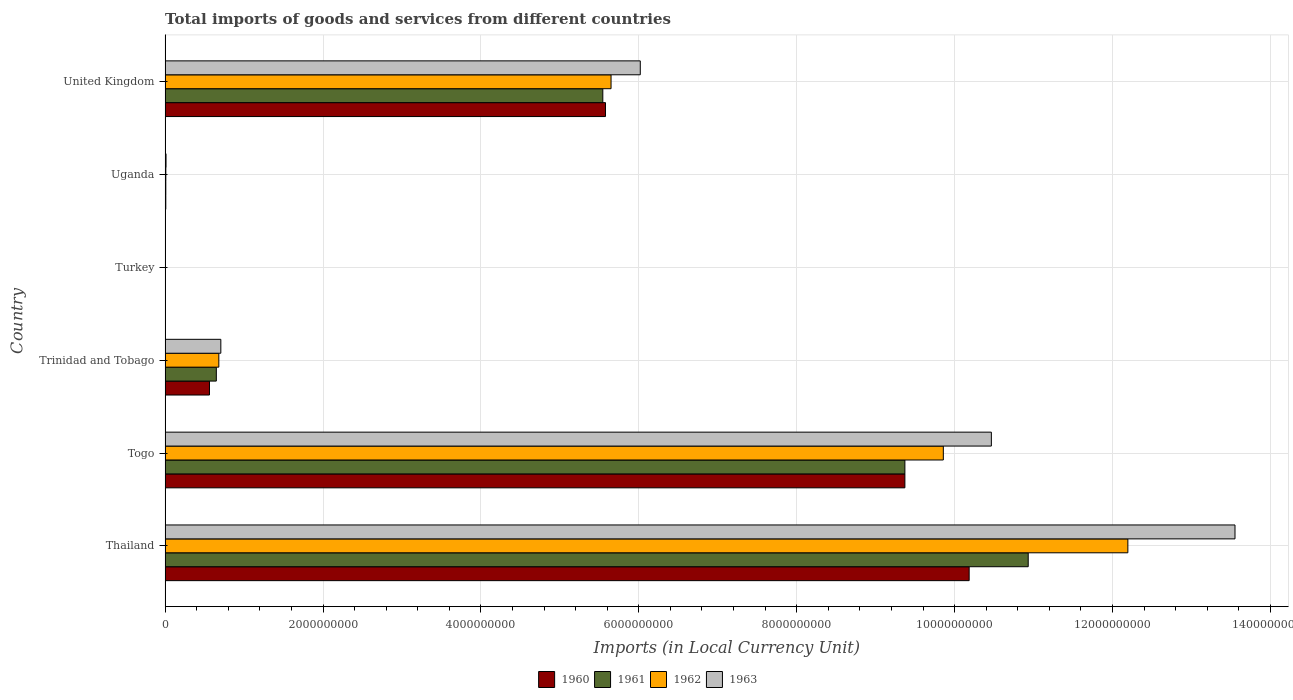What is the label of the 6th group of bars from the top?
Your answer should be very brief. Thailand. In how many cases, is the number of bars for a given country not equal to the number of legend labels?
Provide a short and direct response. 0. What is the Amount of goods and services imports in 1962 in United Kingdom?
Your response must be concise. 5.65e+09. Across all countries, what is the maximum Amount of goods and services imports in 1960?
Provide a short and direct response. 1.02e+1. Across all countries, what is the minimum Amount of goods and services imports in 1961?
Your response must be concise. 4900. In which country was the Amount of goods and services imports in 1960 maximum?
Make the answer very short. Thailand. What is the total Amount of goods and services imports in 1961 in the graph?
Your answer should be compact. 2.65e+1. What is the difference between the Amount of goods and services imports in 1961 in Trinidad and Tobago and that in United Kingdom?
Your answer should be very brief. -4.89e+09. What is the difference between the Amount of goods and services imports in 1962 in Togo and the Amount of goods and services imports in 1963 in Turkey?
Offer a very short reply. 9.86e+09. What is the average Amount of goods and services imports in 1963 per country?
Provide a short and direct response. 5.13e+09. What is the difference between the Amount of goods and services imports in 1962 and Amount of goods and services imports in 1960 in Uganda?
Your response must be concise. 3.83e+05. What is the ratio of the Amount of goods and services imports in 1962 in Togo to that in United Kingdom?
Your answer should be very brief. 1.75. Is the Amount of goods and services imports in 1963 in Thailand less than that in United Kingdom?
Offer a terse response. No. What is the difference between the highest and the second highest Amount of goods and services imports in 1960?
Your answer should be compact. 8.14e+08. What is the difference between the highest and the lowest Amount of goods and services imports in 1963?
Offer a very short reply. 1.36e+1. In how many countries, is the Amount of goods and services imports in 1963 greater than the average Amount of goods and services imports in 1963 taken over all countries?
Offer a terse response. 3. Is the sum of the Amount of goods and services imports in 1962 in Thailand and United Kingdom greater than the maximum Amount of goods and services imports in 1960 across all countries?
Provide a short and direct response. Yes. Is it the case that in every country, the sum of the Amount of goods and services imports in 1961 and Amount of goods and services imports in 1960 is greater than the sum of Amount of goods and services imports in 1963 and Amount of goods and services imports in 1962?
Your answer should be very brief. No. What does the 3rd bar from the top in Uganda represents?
Offer a very short reply. 1961. Are all the bars in the graph horizontal?
Offer a very short reply. Yes. How many countries are there in the graph?
Your response must be concise. 6. Does the graph contain any zero values?
Your answer should be very brief. No. What is the title of the graph?
Your response must be concise. Total imports of goods and services from different countries. Does "1984" appear as one of the legend labels in the graph?
Offer a very short reply. No. What is the label or title of the X-axis?
Your response must be concise. Imports (in Local Currency Unit). What is the label or title of the Y-axis?
Your answer should be compact. Country. What is the Imports (in Local Currency Unit) in 1960 in Thailand?
Provide a succinct answer. 1.02e+1. What is the Imports (in Local Currency Unit) of 1961 in Thailand?
Make the answer very short. 1.09e+1. What is the Imports (in Local Currency Unit) of 1962 in Thailand?
Provide a short and direct response. 1.22e+1. What is the Imports (in Local Currency Unit) in 1963 in Thailand?
Your answer should be very brief. 1.36e+1. What is the Imports (in Local Currency Unit) of 1960 in Togo?
Give a very brief answer. 9.37e+09. What is the Imports (in Local Currency Unit) of 1961 in Togo?
Make the answer very short. 9.37e+09. What is the Imports (in Local Currency Unit) of 1962 in Togo?
Give a very brief answer. 9.86e+09. What is the Imports (in Local Currency Unit) in 1963 in Togo?
Your answer should be very brief. 1.05e+1. What is the Imports (in Local Currency Unit) of 1960 in Trinidad and Tobago?
Offer a very short reply. 5.62e+08. What is the Imports (in Local Currency Unit) in 1961 in Trinidad and Tobago?
Your answer should be very brief. 6.49e+08. What is the Imports (in Local Currency Unit) in 1962 in Trinidad and Tobago?
Your answer should be compact. 6.81e+08. What is the Imports (in Local Currency Unit) in 1963 in Trinidad and Tobago?
Offer a terse response. 7.06e+08. What is the Imports (in Local Currency Unit) in 1960 in Turkey?
Make the answer very short. 2500. What is the Imports (in Local Currency Unit) in 1961 in Turkey?
Provide a succinct answer. 4900. What is the Imports (in Local Currency Unit) of 1962 in Turkey?
Your answer should be very brief. 6400. What is the Imports (in Local Currency Unit) of 1963 in Turkey?
Your answer should be very brief. 6500. What is the Imports (in Local Currency Unit) of 1960 in Uganda?
Your response must be concise. 8.80e+06. What is the Imports (in Local Currency Unit) in 1961 in Uganda?
Keep it short and to the point. 9.12e+06. What is the Imports (in Local Currency Unit) in 1962 in Uganda?
Provide a succinct answer. 9.19e+06. What is the Imports (in Local Currency Unit) in 1963 in Uganda?
Your answer should be very brief. 1.18e+07. What is the Imports (in Local Currency Unit) in 1960 in United Kingdom?
Provide a succinct answer. 5.58e+09. What is the Imports (in Local Currency Unit) of 1961 in United Kingdom?
Provide a short and direct response. 5.54e+09. What is the Imports (in Local Currency Unit) in 1962 in United Kingdom?
Keep it short and to the point. 5.65e+09. What is the Imports (in Local Currency Unit) in 1963 in United Kingdom?
Provide a short and direct response. 6.02e+09. Across all countries, what is the maximum Imports (in Local Currency Unit) in 1960?
Provide a short and direct response. 1.02e+1. Across all countries, what is the maximum Imports (in Local Currency Unit) of 1961?
Keep it short and to the point. 1.09e+1. Across all countries, what is the maximum Imports (in Local Currency Unit) in 1962?
Offer a very short reply. 1.22e+1. Across all countries, what is the maximum Imports (in Local Currency Unit) in 1963?
Give a very brief answer. 1.36e+1. Across all countries, what is the minimum Imports (in Local Currency Unit) of 1960?
Ensure brevity in your answer.  2500. Across all countries, what is the minimum Imports (in Local Currency Unit) of 1961?
Make the answer very short. 4900. Across all countries, what is the minimum Imports (in Local Currency Unit) in 1962?
Offer a terse response. 6400. Across all countries, what is the minimum Imports (in Local Currency Unit) of 1963?
Keep it short and to the point. 6500. What is the total Imports (in Local Currency Unit) in 1960 in the graph?
Provide a succinct answer. 2.57e+1. What is the total Imports (in Local Currency Unit) of 1961 in the graph?
Your answer should be very brief. 2.65e+1. What is the total Imports (in Local Currency Unit) of 1962 in the graph?
Ensure brevity in your answer.  2.84e+1. What is the total Imports (in Local Currency Unit) in 1963 in the graph?
Offer a terse response. 3.08e+1. What is the difference between the Imports (in Local Currency Unit) in 1960 in Thailand and that in Togo?
Your answer should be very brief. 8.14e+08. What is the difference between the Imports (in Local Currency Unit) of 1961 in Thailand and that in Togo?
Your response must be concise. 1.56e+09. What is the difference between the Imports (in Local Currency Unit) in 1962 in Thailand and that in Togo?
Ensure brevity in your answer.  2.34e+09. What is the difference between the Imports (in Local Currency Unit) of 1963 in Thailand and that in Togo?
Make the answer very short. 3.09e+09. What is the difference between the Imports (in Local Currency Unit) in 1960 in Thailand and that in Trinidad and Tobago?
Your answer should be compact. 9.62e+09. What is the difference between the Imports (in Local Currency Unit) in 1961 in Thailand and that in Trinidad and Tobago?
Give a very brief answer. 1.03e+1. What is the difference between the Imports (in Local Currency Unit) of 1962 in Thailand and that in Trinidad and Tobago?
Your response must be concise. 1.15e+1. What is the difference between the Imports (in Local Currency Unit) in 1963 in Thailand and that in Trinidad and Tobago?
Ensure brevity in your answer.  1.28e+1. What is the difference between the Imports (in Local Currency Unit) of 1960 in Thailand and that in Turkey?
Your answer should be compact. 1.02e+1. What is the difference between the Imports (in Local Currency Unit) in 1961 in Thailand and that in Turkey?
Give a very brief answer. 1.09e+1. What is the difference between the Imports (in Local Currency Unit) in 1962 in Thailand and that in Turkey?
Ensure brevity in your answer.  1.22e+1. What is the difference between the Imports (in Local Currency Unit) in 1963 in Thailand and that in Turkey?
Make the answer very short. 1.36e+1. What is the difference between the Imports (in Local Currency Unit) of 1960 in Thailand and that in Uganda?
Keep it short and to the point. 1.02e+1. What is the difference between the Imports (in Local Currency Unit) in 1961 in Thailand and that in Uganda?
Your answer should be compact. 1.09e+1. What is the difference between the Imports (in Local Currency Unit) in 1962 in Thailand and that in Uganda?
Keep it short and to the point. 1.22e+1. What is the difference between the Imports (in Local Currency Unit) of 1963 in Thailand and that in Uganda?
Make the answer very short. 1.35e+1. What is the difference between the Imports (in Local Currency Unit) in 1960 in Thailand and that in United Kingdom?
Make the answer very short. 4.61e+09. What is the difference between the Imports (in Local Currency Unit) in 1961 in Thailand and that in United Kingdom?
Provide a succinct answer. 5.39e+09. What is the difference between the Imports (in Local Currency Unit) in 1962 in Thailand and that in United Kingdom?
Give a very brief answer. 6.55e+09. What is the difference between the Imports (in Local Currency Unit) in 1963 in Thailand and that in United Kingdom?
Offer a very short reply. 7.53e+09. What is the difference between the Imports (in Local Currency Unit) of 1960 in Togo and that in Trinidad and Tobago?
Provide a short and direct response. 8.81e+09. What is the difference between the Imports (in Local Currency Unit) in 1961 in Togo and that in Trinidad and Tobago?
Provide a succinct answer. 8.72e+09. What is the difference between the Imports (in Local Currency Unit) of 1962 in Togo and that in Trinidad and Tobago?
Make the answer very short. 9.18e+09. What is the difference between the Imports (in Local Currency Unit) of 1963 in Togo and that in Trinidad and Tobago?
Give a very brief answer. 9.76e+09. What is the difference between the Imports (in Local Currency Unit) in 1960 in Togo and that in Turkey?
Offer a very short reply. 9.37e+09. What is the difference between the Imports (in Local Currency Unit) of 1961 in Togo and that in Turkey?
Provide a succinct answer. 9.37e+09. What is the difference between the Imports (in Local Currency Unit) of 1962 in Togo and that in Turkey?
Offer a terse response. 9.86e+09. What is the difference between the Imports (in Local Currency Unit) of 1963 in Togo and that in Turkey?
Your response must be concise. 1.05e+1. What is the difference between the Imports (in Local Currency Unit) in 1960 in Togo and that in Uganda?
Ensure brevity in your answer.  9.36e+09. What is the difference between the Imports (in Local Currency Unit) of 1961 in Togo and that in Uganda?
Offer a very short reply. 9.36e+09. What is the difference between the Imports (in Local Currency Unit) of 1962 in Togo and that in Uganda?
Provide a succinct answer. 9.85e+09. What is the difference between the Imports (in Local Currency Unit) of 1963 in Togo and that in Uganda?
Offer a very short reply. 1.05e+1. What is the difference between the Imports (in Local Currency Unit) of 1960 in Togo and that in United Kingdom?
Your answer should be very brief. 3.79e+09. What is the difference between the Imports (in Local Currency Unit) in 1961 in Togo and that in United Kingdom?
Provide a short and direct response. 3.83e+09. What is the difference between the Imports (in Local Currency Unit) in 1962 in Togo and that in United Kingdom?
Your response must be concise. 4.21e+09. What is the difference between the Imports (in Local Currency Unit) in 1963 in Togo and that in United Kingdom?
Provide a succinct answer. 4.45e+09. What is the difference between the Imports (in Local Currency Unit) of 1960 in Trinidad and Tobago and that in Turkey?
Offer a terse response. 5.62e+08. What is the difference between the Imports (in Local Currency Unit) in 1961 in Trinidad and Tobago and that in Turkey?
Make the answer very short. 6.49e+08. What is the difference between the Imports (in Local Currency Unit) in 1962 in Trinidad and Tobago and that in Turkey?
Provide a succinct answer. 6.81e+08. What is the difference between the Imports (in Local Currency Unit) in 1963 in Trinidad and Tobago and that in Turkey?
Your answer should be very brief. 7.06e+08. What is the difference between the Imports (in Local Currency Unit) in 1960 in Trinidad and Tobago and that in Uganda?
Give a very brief answer. 5.53e+08. What is the difference between the Imports (in Local Currency Unit) of 1961 in Trinidad and Tobago and that in Uganda?
Make the answer very short. 6.40e+08. What is the difference between the Imports (in Local Currency Unit) of 1962 in Trinidad and Tobago and that in Uganda?
Provide a succinct answer. 6.71e+08. What is the difference between the Imports (in Local Currency Unit) in 1963 in Trinidad and Tobago and that in Uganda?
Keep it short and to the point. 6.94e+08. What is the difference between the Imports (in Local Currency Unit) of 1960 in Trinidad and Tobago and that in United Kingdom?
Make the answer very short. -5.02e+09. What is the difference between the Imports (in Local Currency Unit) in 1961 in Trinidad and Tobago and that in United Kingdom?
Your response must be concise. -4.89e+09. What is the difference between the Imports (in Local Currency Unit) in 1962 in Trinidad and Tobago and that in United Kingdom?
Your answer should be very brief. -4.97e+09. What is the difference between the Imports (in Local Currency Unit) in 1963 in Trinidad and Tobago and that in United Kingdom?
Offer a very short reply. -5.31e+09. What is the difference between the Imports (in Local Currency Unit) in 1960 in Turkey and that in Uganda?
Make the answer very short. -8.80e+06. What is the difference between the Imports (in Local Currency Unit) in 1961 in Turkey and that in Uganda?
Offer a terse response. -9.11e+06. What is the difference between the Imports (in Local Currency Unit) in 1962 in Turkey and that in Uganda?
Offer a very short reply. -9.18e+06. What is the difference between the Imports (in Local Currency Unit) in 1963 in Turkey and that in Uganda?
Your response must be concise. -1.18e+07. What is the difference between the Imports (in Local Currency Unit) in 1960 in Turkey and that in United Kingdom?
Keep it short and to the point. -5.58e+09. What is the difference between the Imports (in Local Currency Unit) in 1961 in Turkey and that in United Kingdom?
Your answer should be very brief. -5.54e+09. What is the difference between the Imports (in Local Currency Unit) of 1962 in Turkey and that in United Kingdom?
Give a very brief answer. -5.65e+09. What is the difference between the Imports (in Local Currency Unit) of 1963 in Turkey and that in United Kingdom?
Offer a terse response. -6.02e+09. What is the difference between the Imports (in Local Currency Unit) of 1960 in Uganda and that in United Kingdom?
Provide a short and direct response. -5.57e+09. What is the difference between the Imports (in Local Currency Unit) in 1961 in Uganda and that in United Kingdom?
Offer a terse response. -5.53e+09. What is the difference between the Imports (in Local Currency Unit) of 1962 in Uganda and that in United Kingdom?
Ensure brevity in your answer.  -5.64e+09. What is the difference between the Imports (in Local Currency Unit) in 1963 in Uganda and that in United Kingdom?
Ensure brevity in your answer.  -6.01e+09. What is the difference between the Imports (in Local Currency Unit) of 1960 in Thailand and the Imports (in Local Currency Unit) of 1961 in Togo?
Keep it short and to the point. 8.14e+08. What is the difference between the Imports (in Local Currency Unit) in 1960 in Thailand and the Imports (in Local Currency Unit) in 1962 in Togo?
Your answer should be compact. 3.27e+08. What is the difference between the Imports (in Local Currency Unit) in 1960 in Thailand and the Imports (in Local Currency Unit) in 1963 in Togo?
Ensure brevity in your answer.  -2.81e+08. What is the difference between the Imports (in Local Currency Unit) of 1961 in Thailand and the Imports (in Local Currency Unit) of 1962 in Togo?
Your answer should be compact. 1.08e+09. What is the difference between the Imports (in Local Currency Unit) of 1961 in Thailand and the Imports (in Local Currency Unit) of 1963 in Togo?
Keep it short and to the point. 4.67e+08. What is the difference between the Imports (in Local Currency Unit) in 1962 in Thailand and the Imports (in Local Currency Unit) in 1963 in Togo?
Offer a very short reply. 1.73e+09. What is the difference between the Imports (in Local Currency Unit) in 1960 in Thailand and the Imports (in Local Currency Unit) in 1961 in Trinidad and Tobago?
Make the answer very short. 9.54e+09. What is the difference between the Imports (in Local Currency Unit) in 1960 in Thailand and the Imports (in Local Currency Unit) in 1962 in Trinidad and Tobago?
Your response must be concise. 9.50e+09. What is the difference between the Imports (in Local Currency Unit) in 1960 in Thailand and the Imports (in Local Currency Unit) in 1963 in Trinidad and Tobago?
Offer a terse response. 9.48e+09. What is the difference between the Imports (in Local Currency Unit) of 1961 in Thailand and the Imports (in Local Currency Unit) of 1962 in Trinidad and Tobago?
Make the answer very short. 1.03e+1. What is the difference between the Imports (in Local Currency Unit) of 1961 in Thailand and the Imports (in Local Currency Unit) of 1963 in Trinidad and Tobago?
Ensure brevity in your answer.  1.02e+1. What is the difference between the Imports (in Local Currency Unit) in 1962 in Thailand and the Imports (in Local Currency Unit) in 1963 in Trinidad and Tobago?
Your answer should be compact. 1.15e+1. What is the difference between the Imports (in Local Currency Unit) of 1960 in Thailand and the Imports (in Local Currency Unit) of 1961 in Turkey?
Provide a succinct answer. 1.02e+1. What is the difference between the Imports (in Local Currency Unit) in 1960 in Thailand and the Imports (in Local Currency Unit) in 1962 in Turkey?
Give a very brief answer. 1.02e+1. What is the difference between the Imports (in Local Currency Unit) of 1960 in Thailand and the Imports (in Local Currency Unit) of 1963 in Turkey?
Keep it short and to the point. 1.02e+1. What is the difference between the Imports (in Local Currency Unit) of 1961 in Thailand and the Imports (in Local Currency Unit) of 1962 in Turkey?
Keep it short and to the point. 1.09e+1. What is the difference between the Imports (in Local Currency Unit) in 1961 in Thailand and the Imports (in Local Currency Unit) in 1963 in Turkey?
Provide a short and direct response. 1.09e+1. What is the difference between the Imports (in Local Currency Unit) of 1962 in Thailand and the Imports (in Local Currency Unit) of 1963 in Turkey?
Your response must be concise. 1.22e+1. What is the difference between the Imports (in Local Currency Unit) in 1960 in Thailand and the Imports (in Local Currency Unit) in 1961 in Uganda?
Your response must be concise. 1.02e+1. What is the difference between the Imports (in Local Currency Unit) of 1960 in Thailand and the Imports (in Local Currency Unit) of 1962 in Uganda?
Provide a succinct answer. 1.02e+1. What is the difference between the Imports (in Local Currency Unit) in 1960 in Thailand and the Imports (in Local Currency Unit) in 1963 in Uganda?
Offer a terse response. 1.02e+1. What is the difference between the Imports (in Local Currency Unit) of 1961 in Thailand and the Imports (in Local Currency Unit) of 1962 in Uganda?
Provide a succinct answer. 1.09e+1. What is the difference between the Imports (in Local Currency Unit) of 1961 in Thailand and the Imports (in Local Currency Unit) of 1963 in Uganda?
Offer a very short reply. 1.09e+1. What is the difference between the Imports (in Local Currency Unit) in 1962 in Thailand and the Imports (in Local Currency Unit) in 1963 in Uganda?
Offer a very short reply. 1.22e+1. What is the difference between the Imports (in Local Currency Unit) of 1960 in Thailand and the Imports (in Local Currency Unit) of 1961 in United Kingdom?
Give a very brief answer. 4.64e+09. What is the difference between the Imports (in Local Currency Unit) of 1960 in Thailand and the Imports (in Local Currency Unit) of 1962 in United Kingdom?
Keep it short and to the point. 4.54e+09. What is the difference between the Imports (in Local Currency Unit) of 1960 in Thailand and the Imports (in Local Currency Unit) of 1963 in United Kingdom?
Your answer should be very brief. 4.17e+09. What is the difference between the Imports (in Local Currency Unit) of 1961 in Thailand and the Imports (in Local Currency Unit) of 1962 in United Kingdom?
Your answer should be very brief. 5.28e+09. What is the difference between the Imports (in Local Currency Unit) of 1961 in Thailand and the Imports (in Local Currency Unit) of 1963 in United Kingdom?
Make the answer very short. 4.91e+09. What is the difference between the Imports (in Local Currency Unit) of 1962 in Thailand and the Imports (in Local Currency Unit) of 1963 in United Kingdom?
Your response must be concise. 6.18e+09. What is the difference between the Imports (in Local Currency Unit) of 1960 in Togo and the Imports (in Local Currency Unit) of 1961 in Trinidad and Tobago?
Your answer should be compact. 8.72e+09. What is the difference between the Imports (in Local Currency Unit) in 1960 in Togo and the Imports (in Local Currency Unit) in 1962 in Trinidad and Tobago?
Your answer should be compact. 8.69e+09. What is the difference between the Imports (in Local Currency Unit) of 1960 in Togo and the Imports (in Local Currency Unit) of 1963 in Trinidad and Tobago?
Provide a succinct answer. 8.66e+09. What is the difference between the Imports (in Local Currency Unit) of 1961 in Togo and the Imports (in Local Currency Unit) of 1962 in Trinidad and Tobago?
Provide a short and direct response. 8.69e+09. What is the difference between the Imports (in Local Currency Unit) of 1961 in Togo and the Imports (in Local Currency Unit) of 1963 in Trinidad and Tobago?
Keep it short and to the point. 8.66e+09. What is the difference between the Imports (in Local Currency Unit) of 1962 in Togo and the Imports (in Local Currency Unit) of 1963 in Trinidad and Tobago?
Provide a succinct answer. 9.15e+09. What is the difference between the Imports (in Local Currency Unit) in 1960 in Togo and the Imports (in Local Currency Unit) in 1961 in Turkey?
Offer a terse response. 9.37e+09. What is the difference between the Imports (in Local Currency Unit) of 1960 in Togo and the Imports (in Local Currency Unit) of 1962 in Turkey?
Offer a very short reply. 9.37e+09. What is the difference between the Imports (in Local Currency Unit) in 1960 in Togo and the Imports (in Local Currency Unit) in 1963 in Turkey?
Make the answer very short. 9.37e+09. What is the difference between the Imports (in Local Currency Unit) of 1961 in Togo and the Imports (in Local Currency Unit) of 1962 in Turkey?
Keep it short and to the point. 9.37e+09. What is the difference between the Imports (in Local Currency Unit) of 1961 in Togo and the Imports (in Local Currency Unit) of 1963 in Turkey?
Give a very brief answer. 9.37e+09. What is the difference between the Imports (in Local Currency Unit) in 1962 in Togo and the Imports (in Local Currency Unit) in 1963 in Turkey?
Ensure brevity in your answer.  9.86e+09. What is the difference between the Imports (in Local Currency Unit) of 1960 in Togo and the Imports (in Local Currency Unit) of 1961 in Uganda?
Make the answer very short. 9.36e+09. What is the difference between the Imports (in Local Currency Unit) of 1960 in Togo and the Imports (in Local Currency Unit) of 1962 in Uganda?
Ensure brevity in your answer.  9.36e+09. What is the difference between the Imports (in Local Currency Unit) of 1960 in Togo and the Imports (in Local Currency Unit) of 1963 in Uganda?
Give a very brief answer. 9.36e+09. What is the difference between the Imports (in Local Currency Unit) in 1961 in Togo and the Imports (in Local Currency Unit) in 1962 in Uganda?
Provide a succinct answer. 9.36e+09. What is the difference between the Imports (in Local Currency Unit) in 1961 in Togo and the Imports (in Local Currency Unit) in 1963 in Uganda?
Make the answer very short. 9.36e+09. What is the difference between the Imports (in Local Currency Unit) in 1962 in Togo and the Imports (in Local Currency Unit) in 1963 in Uganda?
Make the answer very short. 9.85e+09. What is the difference between the Imports (in Local Currency Unit) in 1960 in Togo and the Imports (in Local Currency Unit) in 1961 in United Kingdom?
Your answer should be very brief. 3.83e+09. What is the difference between the Imports (in Local Currency Unit) of 1960 in Togo and the Imports (in Local Currency Unit) of 1962 in United Kingdom?
Your response must be concise. 3.72e+09. What is the difference between the Imports (in Local Currency Unit) of 1960 in Togo and the Imports (in Local Currency Unit) of 1963 in United Kingdom?
Your answer should be very brief. 3.35e+09. What is the difference between the Imports (in Local Currency Unit) of 1961 in Togo and the Imports (in Local Currency Unit) of 1962 in United Kingdom?
Provide a succinct answer. 3.72e+09. What is the difference between the Imports (in Local Currency Unit) of 1961 in Togo and the Imports (in Local Currency Unit) of 1963 in United Kingdom?
Give a very brief answer. 3.35e+09. What is the difference between the Imports (in Local Currency Unit) of 1962 in Togo and the Imports (in Local Currency Unit) of 1963 in United Kingdom?
Give a very brief answer. 3.84e+09. What is the difference between the Imports (in Local Currency Unit) of 1960 in Trinidad and Tobago and the Imports (in Local Currency Unit) of 1961 in Turkey?
Keep it short and to the point. 5.62e+08. What is the difference between the Imports (in Local Currency Unit) of 1960 in Trinidad and Tobago and the Imports (in Local Currency Unit) of 1962 in Turkey?
Give a very brief answer. 5.62e+08. What is the difference between the Imports (in Local Currency Unit) in 1960 in Trinidad and Tobago and the Imports (in Local Currency Unit) in 1963 in Turkey?
Provide a short and direct response. 5.62e+08. What is the difference between the Imports (in Local Currency Unit) in 1961 in Trinidad and Tobago and the Imports (in Local Currency Unit) in 1962 in Turkey?
Offer a very short reply. 6.49e+08. What is the difference between the Imports (in Local Currency Unit) of 1961 in Trinidad and Tobago and the Imports (in Local Currency Unit) of 1963 in Turkey?
Offer a very short reply. 6.49e+08. What is the difference between the Imports (in Local Currency Unit) in 1962 in Trinidad and Tobago and the Imports (in Local Currency Unit) in 1963 in Turkey?
Your answer should be very brief. 6.81e+08. What is the difference between the Imports (in Local Currency Unit) in 1960 in Trinidad and Tobago and the Imports (in Local Currency Unit) in 1961 in Uganda?
Your answer should be very brief. 5.53e+08. What is the difference between the Imports (in Local Currency Unit) in 1960 in Trinidad and Tobago and the Imports (in Local Currency Unit) in 1962 in Uganda?
Your answer should be compact. 5.53e+08. What is the difference between the Imports (in Local Currency Unit) in 1960 in Trinidad and Tobago and the Imports (in Local Currency Unit) in 1963 in Uganda?
Your answer should be compact. 5.50e+08. What is the difference between the Imports (in Local Currency Unit) of 1961 in Trinidad and Tobago and the Imports (in Local Currency Unit) of 1962 in Uganda?
Ensure brevity in your answer.  6.40e+08. What is the difference between the Imports (in Local Currency Unit) in 1961 in Trinidad and Tobago and the Imports (in Local Currency Unit) in 1963 in Uganda?
Give a very brief answer. 6.37e+08. What is the difference between the Imports (in Local Currency Unit) of 1962 in Trinidad and Tobago and the Imports (in Local Currency Unit) of 1963 in Uganda?
Give a very brief answer. 6.69e+08. What is the difference between the Imports (in Local Currency Unit) of 1960 in Trinidad and Tobago and the Imports (in Local Currency Unit) of 1961 in United Kingdom?
Keep it short and to the point. -4.98e+09. What is the difference between the Imports (in Local Currency Unit) in 1960 in Trinidad and Tobago and the Imports (in Local Currency Unit) in 1962 in United Kingdom?
Make the answer very short. -5.09e+09. What is the difference between the Imports (in Local Currency Unit) of 1960 in Trinidad and Tobago and the Imports (in Local Currency Unit) of 1963 in United Kingdom?
Make the answer very short. -5.46e+09. What is the difference between the Imports (in Local Currency Unit) of 1961 in Trinidad and Tobago and the Imports (in Local Currency Unit) of 1962 in United Kingdom?
Your answer should be very brief. -5.00e+09. What is the difference between the Imports (in Local Currency Unit) in 1961 in Trinidad and Tobago and the Imports (in Local Currency Unit) in 1963 in United Kingdom?
Your answer should be very brief. -5.37e+09. What is the difference between the Imports (in Local Currency Unit) in 1962 in Trinidad and Tobago and the Imports (in Local Currency Unit) in 1963 in United Kingdom?
Make the answer very short. -5.34e+09. What is the difference between the Imports (in Local Currency Unit) in 1960 in Turkey and the Imports (in Local Currency Unit) in 1961 in Uganda?
Offer a very short reply. -9.11e+06. What is the difference between the Imports (in Local Currency Unit) of 1960 in Turkey and the Imports (in Local Currency Unit) of 1962 in Uganda?
Your response must be concise. -9.18e+06. What is the difference between the Imports (in Local Currency Unit) in 1960 in Turkey and the Imports (in Local Currency Unit) in 1963 in Uganda?
Offer a very short reply. -1.18e+07. What is the difference between the Imports (in Local Currency Unit) of 1961 in Turkey and the Imports (in Local Currency Unit) of 1962 in Uganda?
Your response must be concise. -9.18e+06. What is the difference between the Imports (in Local Currency Unit) in 1961 in Turkey and the Imports (in Local Currency Unit) in 1963 in Uganda?
Make the answer very short. -1.18e+07. What is the difference between the Imports (in Local Currency Unit) of 1962 in Turkey and the Imports (in Local Currency Unit) of 1963 in Uganda?
Your response must be concise. -1.18e+07. What is the difference between the Imports (in Local Currency Unit) of 1960 in Turkey and the Imports (in Local Currency Unit) of 1961 in United Kingdom?
Keep it short and to the point. -5.54e+09. What is the difference between the Imports (in Local Currency Unit) of 1960 in Turkey and the Imports (in Local Currency Unit) of 1962 in United Kingdom?
Keep it short and to the point. -5.65e+09. What is the difference between the Imports (in Local Currency Unit) of 1960 in Turkey and the Imports (in Local Currency Unit) of 1963 in United Kingdom?
Offer a very short reply. -6.02e+09. What is the difference between the Imports (in Local Currency Unit) in 1961 in Turkey and the Imports (in Local Currency Unit) in 1962 in United Kingdom?
Offer a very short reply. -5.65e+09. What is the difference between the Imports (in Local Currency Unit) in 1961 in Turkey and the Imports (in Local Currency Unit) in 1963 in United Kingdom?
Make the answer very short. -6.02e+09. What is the difference between the Imports (in Local Currency Unit) of 1962 in Turkey and the Imports (in Local Currency Unit) of 1963 in United Kingdom?
Ensure brevity in your answer.  -6.02e+09. What is the difference between the Imports (in Local Currency Unit) in 1960 in Uganda and the Imports (in Local Currency Unit) in 1961 in United Kingdom?
Your answer should be compact. -5.54e+09. What is the difference between the Imports (in Local Currency Unit) in 1960 in Uganda and the Imports (in Local Currency Unit) in 1962 in United Kingdom?
Keep it short and to the point. -5.64e+09. What is the difference between the Imports (in Local Currency Unit) in 1960 in Uganda and the Imports (in Local Currency Unit) in 1963 in United Kingdom?
Offer a terse response. -6.01e+09. What is the difference between the Imports (in Local Currency Unit) in 1961 in Uganda and the Imports (in Local Currency Unit) in 1962 in United Kingdom?
Offer a very short reply. -5.64e+09. What is the difference between the Imports (in Local Currency Unit) in 1961 in Uganda and the Imports (in Local Currency Unit) in 1963 in United Kingdom?
Offer a very short reply. -6.01e+09. What is the difference between the Imports (in Local Currency Unit) in 1962 in Uganda and the Imports (in Local Currency Unit) in 1963 in United Kingdom?
Your answer should be very brief. -6.01e+09. What is the average Imports (in Local Currency Unit) of 1960 per country?
Offer a very short reply. 4.28e+09. What is the average Imports (in Local Currency Unit) in 1961 per country?
Your response must be concise. 4.42e+09. What is the average Imports (in Local Currency Unit) in 1962 per country?
Provide a succinct answer. 4.73e+09. What is the average Imports (in Local Currency Unit) in 1963 per country?
Your response must be concise. 5.13e+09. What is the difference between the Imports (in Local Currency Unit) of 1960 and Imports (in Local Currency Unit) of 1961 in Thailand?
Offer a very short reply. -7.48e+08. What is the difference between the Imports (in Local Currency Unit) of 1960 and Imports (in Local Currency Unit) of 1962 in Thailand?
Make the answer very short. -2.01e+09. What is the difference between the Imports (in Local Currency Unit) of 1960 and Imports (in Local Currency Unit) of 1963 in Thailand?
Your response must be concise. -3.37e+09. What is the difference between the Imports (in Local Currency Unit) in 1961 and Imports (in Local Currency Unit) in 1962 in Thailand?
Your answer should be compact. -1.26e+09. What is the difference between the Imports (in Local Currency Unit) of 1961 and Imports (in Local Currency Unit) of 1963 in Thailand?
Provide a succinct answer. -2.62e+09. What is the difference between the Imports (in Local Currency Unit) of 1962 and Imports (in Local Currency Unit) of 1963 in Thailand?
Offer a terse response. -1.36e+09. What is the difference between the Imports (in Local Currency Unit) of 1960 and Imports (in Local Currency Unit) of 1962 in Togo?
Offer a terse response. -4.87e+08. What is the difference between the Imports (in Local Currency Unit) in 1960 and Imports (in Local Currency Unit) in 1963 in Togo?
Provide a short and direct response. -1.10e+09. What is the difference between the Imports (in Local Currency Unit) in 1961 and Imports (in Local Currency Unit) in 1962 in Togo?
Ensure brevity in your answer.  -4.87e+08. What is the difference between the Imports (in Local Currency Unit) in 1961 and Imports (in Local Currency Unit) in 1963 in Togo?
Give a very brief answer. -1.10e+09. What is the difference between the Imports (in Local Currency Unit) in 1962 and Imports (in Local Currency Unit) in 1963 in Togo?
Your response must be concise. -6.08e+08. What is the difference between the Imports (in Local Currency Unit) of 1960 and Imports (in Local Currency Unit) of 1961 in Trinidad and Tobago?
Offer a terse response. -8.67e+07. What is the difference between the Imports (in Local Currency Unit) of 1960 and Imports (in Local Currency Unit) of 1962 in Trinidad and Tobago?
Give a very brief answer. -1.18e+08. What is the difference between the Imports (in Local Currency Unit) in 1960 and Imports (in Local Currency Unit) in 1963 in Trinidad and Tobago?
Your answer should be compact. -1.44e+08. What is the difference between the Imports (in Local Currency Unit) in 1961 and Imports (in Local Currency Unit) in 1962 in Trinidad and Tobago?
Your response must be concise. -3.17e+07. What is the difference between the Imports (in Local Currency Unit) of 1961 and Imports (in Local Currency Unit) of 1963 in Trinidad and Tobago?
Your response must be concise. -5.69e+07. What is the difference between the Imports (in Local Currency Unit) in 1962 and Imports (in Local Currency Unit) in 1963 in Trinidad and Tobago?
Provide a succinct answer. -2.52e+07. What is the difference between the Imports (in Local Currency Unit) in 1960 and Imports (in Local Currency Unit) in 1961 in Turkey?
Ensure brevity in your answer.  -2400. What is the difference between the Imports (in Local Currency Unit) in 1960 and Imports (in Local Currency Unit) in 1962 in Turkey?
Offer a terse response. -3900. What is the difference between the Imports (in Local Currency Unit) of 1960 and Imports (in Local Currency Unit) of 1963 in Turkey?
Offer a terse response. -4000. What is the difference between the Imports (in Local Currency Unit) in 1961 and Imports (in Local Currency Unit) in 1962 in Turkey?
Offer a terse response. -1500. What is the difference between the Imports (in Local Currency Unit) in 1961 and Imports (in Local Currency Unit) in 1963 in Turkey?
Provide a succinct answer. -1600. What is the difference between the Imports (in Local Currency Unit) in 1962 and Imports (in Local Currency Unit) in 1963 in Turkey?
Your response must be concise. -100. What is the difference between the Imports (in Local Currency Unit) of 1960 and Imports (in Local Currency Unit) of 1961 in Uganda?
Your answer should be very brief. -3.13e+05. What is the difference between the Imports (in Local Currency Unit) in 1960 and Imports (in Local Currency Unit) in 1962 in Uganda?
Your answer should be compact. -3.83e+05. What is the difference between the Imports (in Local Currency Unit) of 1960 and Imports (in Local Currency Unit) of 1963 in Uganda?
Keep it short and to the point. -2.95e+06. What is the difference between the Imports (in Local Currency Unit) of 1961 and Imports (in Local Currency Unit) of 1962 in Uganda?
Your answer should be compact. -7.06e+04. What is the difference between the Imports (in Local Currency Unit) in 1961 and Imports (in Local Currency Unit) in 1963 in Uganda?
Offer a very short reply. -2.64e+06. What is the difference between the Imports (in Local Currency Unit) in 1962 and Imports (in Local Currency Unit) in 1963 in Uganda?
Keep it short and to the point. -2.57e+06. What is the difference between the Imports (in Local Currency Unit) in 1960 and Imports (in Local Currency Unit) in 1961 in United Kingdom?
Offer a very short reply. 3.38e+07. What is the difference between the Imports (in Local Currency Unit) of 1960 and Imports (in Local Currency Unit) of 1962 in United Kingdom?
Ensure brevity in your answer.  -7.06e+07. What is the difference between the Imports (in Local Currency Unit) in 1960 and Imports (in Local Currency Unit) in 1963 in United Kingdom?
Provide a short and direct response. -4.41e+08. What is the difference between the Imports (in Local Currency Unit) of 1961 and Imports (in Local Currency Unit) of 1962 in United Kingdom?
Your answer should be very brief. -1.04e+08. What is the difference between the Imports (in Local Currency Unit) of 1961 and Imports (in Local Currency Unit) of 1963 in United Kingdom?
Provide a succinct answer. -4.75e+08. What is the difference between the Imports (in Local Currency Unit) of 1962 and Imports (in Local Currency Unit) of 1963 in United Kingdom?
Make the answer very short. -3.70e+08. What is the ratio of the Imports (in Local Currency Unit) of 1960 in Thailand to that in Togo?
Make the answer very short. 1.09. What is the ratio of the Imports (in Local Currency Unit) in 1962 in Thailand to that in Togo?
Your answer should be compact. 1.24. What is the ratio of the Imports (in Local Currency Unit) in 1963 in Thailand to that in Togo?
Offer a very short reply. 1.29. What is the ratio of the Imports (in Local Currency Unit) in 1960 in Thailand to that in Trinidad and Tobago?
Ensure brevity in your answer.  18.11. What is the ratio of the Imports (in Local Currency Unit) in 1961 in Thailand to that in Trinidad and Tobago?
Give a very brief answer. 16.85. What is the ratio of the Imports (in Local Currency Unit) of 1962 in Thailand to that in Trinidad and Tobago?
Your answer should be compact. 17.92. What is the ratio of the Imports (in Local Currency Unit) of 1963 in Thailand to that in Trinidad and Tobago?
Offer a very short reply. 19.2. What is the ratio of the Imports (in Local Currency Unit) in 1960 in Thailand to that in Turkey?
Ensure brevity in your answer.  4.07e+06. What is the ratio of the Imports (in Local Currency Unit) of 1961 in Thailand to that in Turkey?
Offer a very short reply. 2.23e+06. What is the ratio of the Imports (in Local Currency Unit) of 1962 in Thailand to that in Turkey?
Ensure brevity in your answer.  1.91e+06. What is the ratio of the Imports (in Local Currency Unit) of 1963 in Thailand to that in Turkey?
Your answer should be compact. 2.08e+06. What is the ratio of the Imports (in Local Currency Unit) of 1960 in Thailand to that in Uganda?
Keep it short and to the point. 1156.75. What is the ratio of the Imports (in Local Currency Unit) in 1961 in Thailand to that in Uganda?
Your answer should be very brief. 1199.12. What is the ratio of the Imports (in Local Currency Unit) in 1962 in Thailand to that in Uganda?
Give a very brief answer. 1327.27. What is the ratio of the Imports (in Local Currency Unit) in 1963 in Thailand to that in Uganda?
Your response must be concise. 1152.4. What is the ratio of the Imports (in Local Currency Unit) in 1960 in Thailand to that in United Kingdom?
Ensure brevity in your answer.  1.83. What is the ratio of the Imports (in Local Currency Unit) in 1961 in Thailand to that in United Kingdom?
Your answer should be compact. 1.97. What is the ratio of the Imports (in Local Currency Unit) of 1962 in Thailand to that in United Kingdom?
Keep it short and to the point. 2.16. What is the ratio of the Imports (in Local Currency Unit) in 1963 in Thailand to that in United Kingdom?
Keep it short and to the point. 2.25. What is the ratio of the Imports (in Local Currency Unit) of 1960 in Togo to that in Trinidad and Tobago?
Your answer should be very brief. 16.67. What is the ratio of the Imports (in Local Currency Unit) in 1961 in Togo to that in Trinidad and Tobago?
Keep it short and to the point. 14.44. What is the ratio of the Imports (in Local Currency Unit) of 1962 in Togo to that in Trinidad and Tobago?
Ensure brevity in your answer.  14.48. What is the ratio of the Imports (in Local Currency Unit) in 1963 in Togo to that in Trinidad and Tobago?
Your answer should be compact. 14.83. What is the ratio of the Imports (in Local Currency Unit) of 1960 in Togo to that in Turkey?
Ensure brevity in your answer.  3.75e+06. What is the ratio of the Imports (in Local Currency Unit) of 1961 in Togo to that in Turkey?
Ensure brevity in your answer.  1.91e+06. What is the ratio of the Imports (in Local Currency Unit) in 1962 in Togo to that in Turkey?
Your answer should be compact. 1.54e+06. What is the ratio of the Imports (in Local Currency Unit) of 1963 in Togo to that in Turkey?
Give a very brief answer. 1.61e+06. What is the ratio of the Imports (in Local Currency Unit) in 1960 in Togo to that in Uganda?
Provide a short and direct response. 1064.29. What is the ratio of the Imports (in Local Currency Unit) of 1961 in Togo to that in Uganda?
Your response must be concise. 1027.79. What is the ratio of the Imports (in Local Currency Unit) of 1962 in Togo to that in Uganda?
Your response must be concise. 1072.87. What is the ratio of the Imports (in Local Currency Unit) of 1963 in Togo to that in Uganda?
Your answer should be very brief. 889.99. What is the ratio of the Imports (in Local Currency Unit) of 1960 in Togo to that in United Kingdom?
Offer a terse response. 1.68. What is the ratio of the Imports (in Local Currency Unit) of 1961 in Togo to that in United Kingdom?
Offer a terse response. 1.69. What is the ratio of the Imports (in Local Currency Unit) in 1962 in Togo to that in United Kingdom?
Provide a succinct answer. 1.75. What is the ratio of the Imports (in Local Currency Unit) of 1963 in Togo to that in United Kingdom?
Your answer should be very brief. 1.74. What is the ratio of the Imports (in Local Currency Unit) in 1960 in Trinidad and Tobago to that in Turkey?
Your answer should be very brief. 2.25e+05. What is the ratio of the Imports (in Local Currency Unit) in 1961 in Trinidad and Tobago to that in Turkey?
Ensure brevity in your answer.  1.32e+05. What is the ratio of the Imports (in Local Currency Unit) in 1962 in Trinidad and Tobago to that in Turkey?
Ensure brevity in your answer.  1.06e+05. What is the ratio of the Imports (in Local Currency Unit) in 1963 in Trinidad and Tobago to that in Turkey?
Keep it short and to the point. 1.09e+05. What is the ratio of the Imports (in Local Currency Unit) of 1960 in Trinidad and Tobago to that in Uganda?
Your response must be concise. 63.86. What is the ratio of the Imports (in Local Currency Unit) of 1961 in Trinidad and Tobago to that in Uganda?
Provide a succinct answer. 71.18. What is the ratio of the Imports (in Local Currency Unit) in 1962 in Trinidad and Tobago to that in Uganda?
Provide a succinct answer. 74.08. What is the ratio of the Imports (in Local Currency Unit) of 1963 in Trinidad and Tobago to that in Uganda?
Provide a short and direct response. 60.02. What is the ratio of the Imports (in Local Currency Unit) in 1960 in Trinidad and Tobago to that in United Kingdom?
Provide a succinct answer. 0.1. What is the ratio of the Imports (in Local Currency Unit) in 1961 in Trinidad and Tobago to that in United Kingdom?
Offer a terse response. 0.12. What is the ratio of the Imports (in Local Currency Unit) of 1962 in Trinidad and Tobago to that in United Kingdom?
Provide a succinct answer. 0.12. What is the ratio of the Imports (in Local Currency Unit) in 1963 in Trinidad and Tobago to that in United Kingdom?
Your response must be concise. 0.12. What is the ratio of the Imports (in Local Currency Unit) in 1961 in Turkey to that in Uganda?
Your answer should be very brief. 0. What is the ratio of the Imports (in Local Currency Unit) in 1962 in Turkey to that in Uganda?
Make the answer very short. 0. What is the ratio of the Imports (in Local Currency Unit) in 1963 in Turkey to that in Uganda?
Keep it short and to the point. 0. What is the ratio of the Imports (in Local Currency Unit) of 1961 in Turkey to that in United Kingdom?
Ensure brevity in your answer.  0. What is the ratio of the Imports (in Local Currency Unit) of 1960 in Uganda to that in United Kingdom?
Your answer should be compact. 0. What is the ratio of the Imports (in Local Currency Unit) of 1961 in Uganda to that in United Kingdom?
Your answer should be very brief. 0. What is the ratio of the Imports (in Local Currency Unit) in 1962 in Uganda to that in United Kingdom?
Your response must be concise. 0. What is the ratio of the Imports (in Local Currency Unit) in 1963 in Uganda to that in United Kingdom?
Offer a terse response. 0. What is the difference between the highest and the second highest Imports (in Local Currency Unit) of 1960?
Keep it short and to the point. 8.14e+08. What is the difference between the highest and the second highest Imports (in Local Currency Unit) in 1961?
Provide a succinct answer. 1.56e+09. What is the difference between the highest and the second highest Imports (in Local Currency Unit) of 1962?
Provide a succinct answer. 2.34e+09. What is the difference between the highest and the second highest Imports (in Local Currency Unit) of 1963?
Offer a very short reply. 3.09e+09. What is the difference between the highest and the lowest Imports (in Local Currency Unit) of 1960?
Provide a short and direct response. 1.02e+1. What is the difference between the highest and the lowest Imports (in Local Currency Unit) in 1961?
Keep it short and to the point. 1.09e+1. What is the difference between the highest and the lowest Imports (in Local Currency Unit) in 1962?
Offer a very short reply. 1.22e+1. What is the difference between the highest and the lowest Imports (in Local Currency Unit) in 1963?
Give a very brief answer. 1.36e+1. 